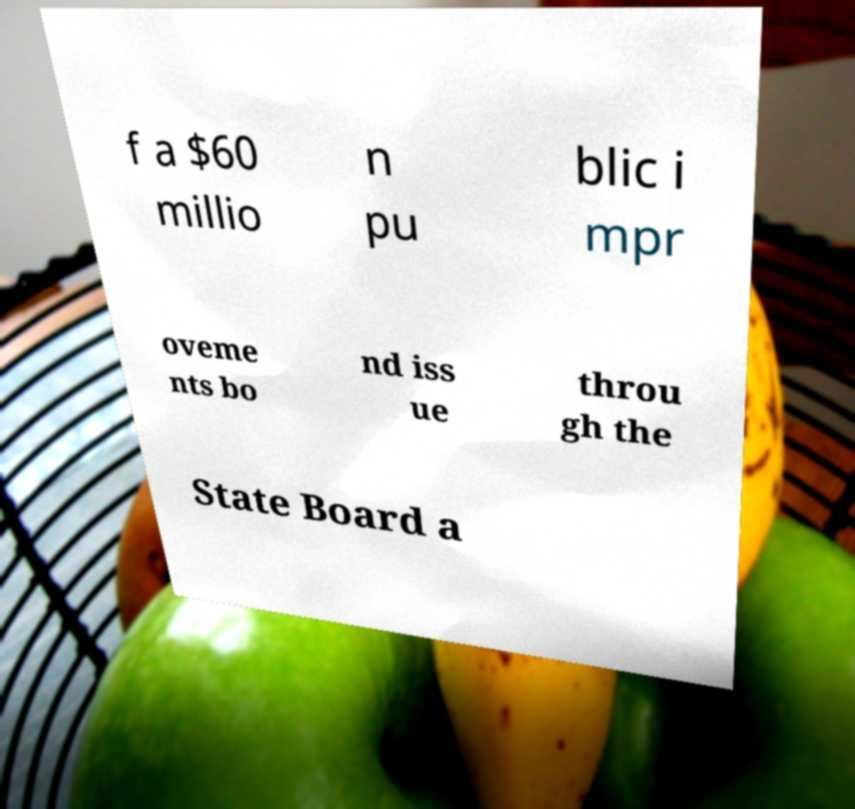Can you accurately transcribe the text from the provided image for me? f a $60 millio n pu blic i mpr oveme nts bo nd iss ue throu gh the State Board a 